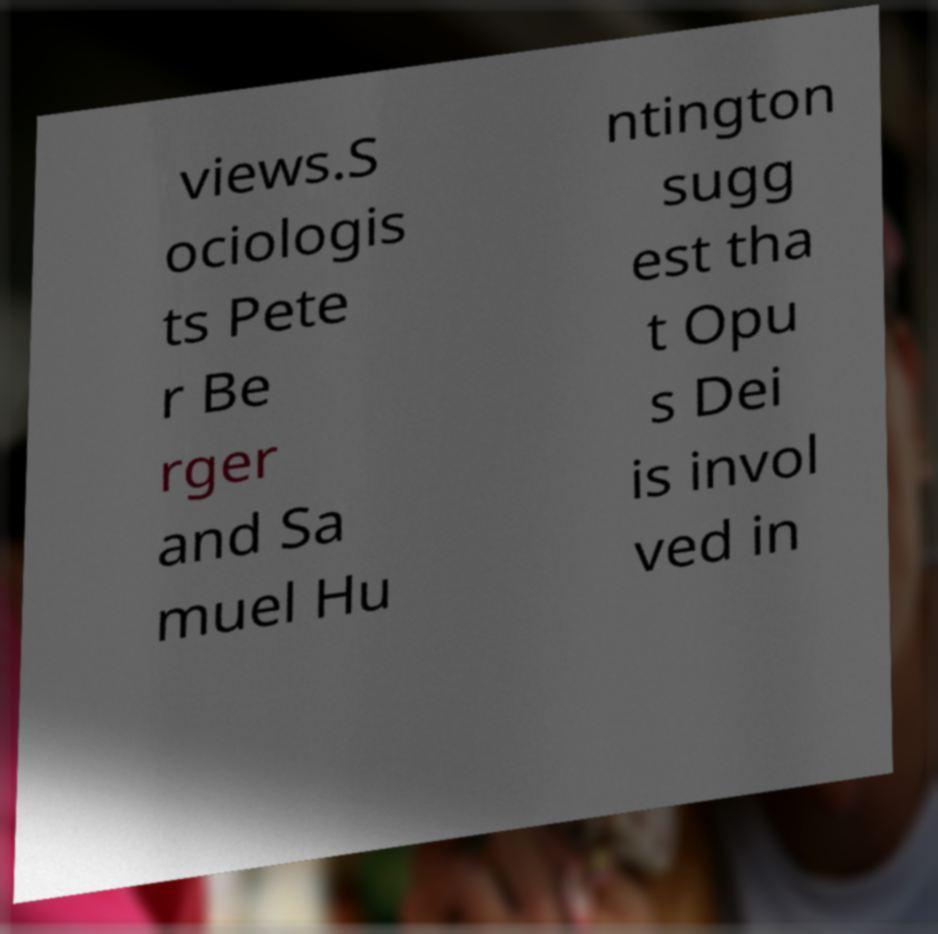What messages or text are displayed in this image? I need them in a readable, typed format. views.S ociologis ts Pete r Be rger and Sa muel Hu ntington sugg est tha t Opu s Dei is invol ved in 